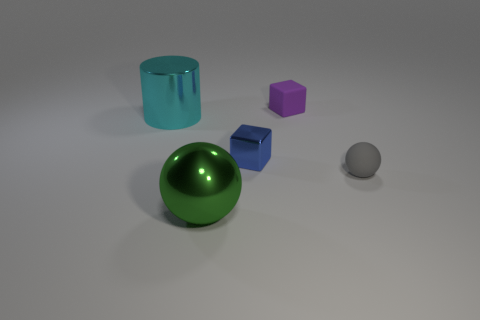Add 2 cubes. How many objects exist? 7 Subtract all blue cubes. Subtract all brown balls. How many cubes are left? 1 Subtract all balls. How many objects are left? 3 Add 1 green things. How many green things are left? 2 Add 3 tiny purple blocks. How many tiny purple blocks exist? 4 Subtract 0 yellow cubes. How many objects are left? 5 Subtract all large green metallic things. Subtract all small purple matte things. How many objects are left? 3 